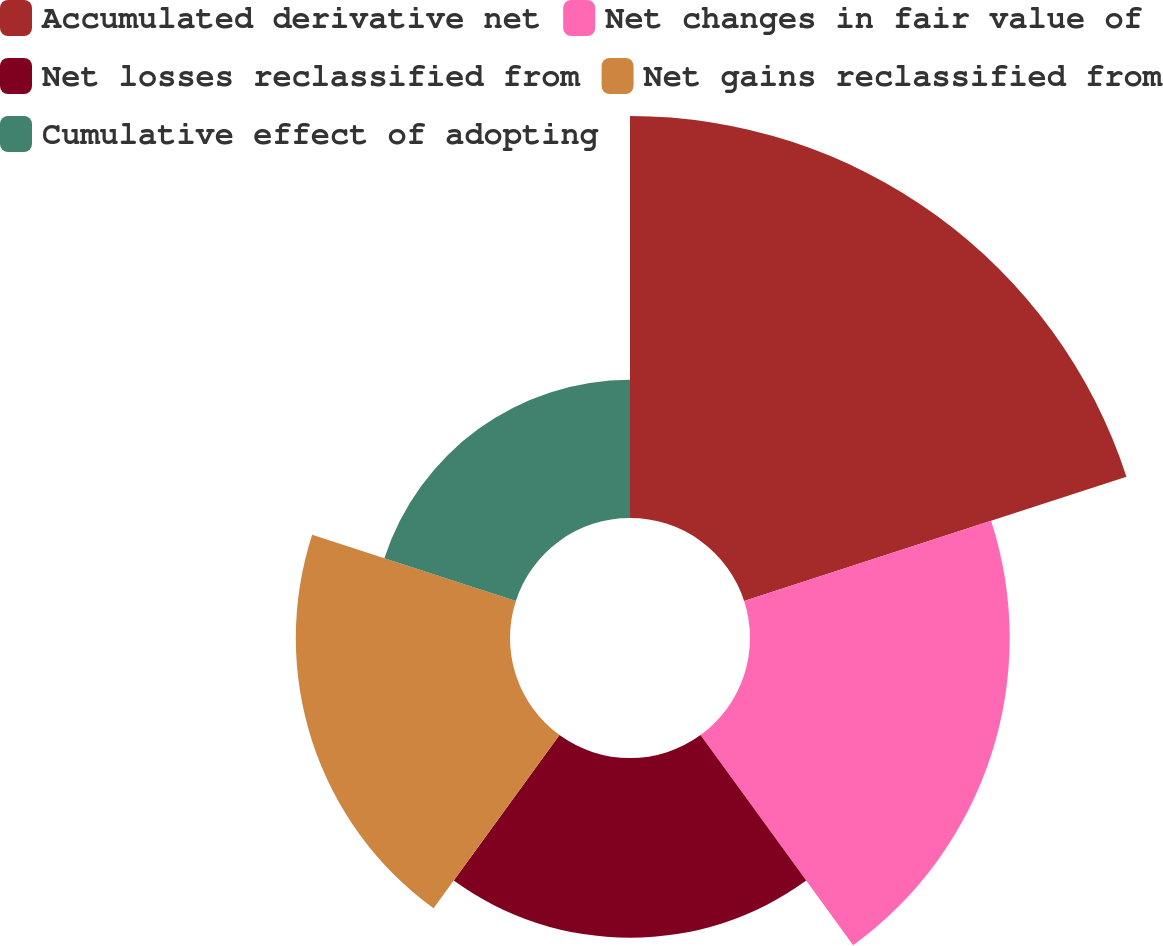Convert chart. <chart><loc_0><loc_0><loc_500><loc_500><pie_chart><fcel>Accumulated derivative net<fcel>Net changes in fair value of<fcel>Net losses reclassified from<fcel>Net gains reclassified from<fcel>Cumulative effect of adopting<nl><fcel>33.67%<fcel>21.75%<fcel>15.06%<fcel>17.94%<fcel>11.58%<nl></chart> 